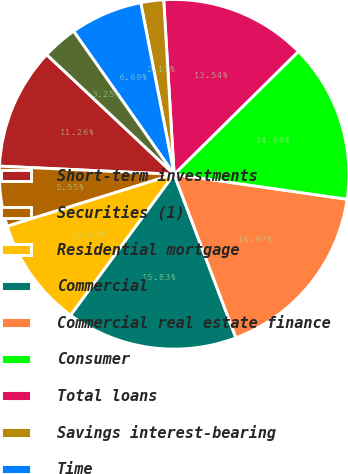<chart> <loc_0><loc_0><loc_500><loc_500><pie_chart><fcel>Short-term investments<fcel>Securities (1)<fcel>Residential mortgage<fcel>Commercial<fcel>Commercial real estate finance<fcel>Consumer<fcel>Total loans<fcel>Savings interest-bearing<fcel>Time<fcel>Total deposits<nl><fcel>11.26%<fcel>5.55%<fcel>10.12%<fcel>15.83%<fcel>16.97%<fcel>14.69%<fcel>13.54%<fcel>2.11%<fcel>6.69%<fcel>3.25%<nl></chart> 